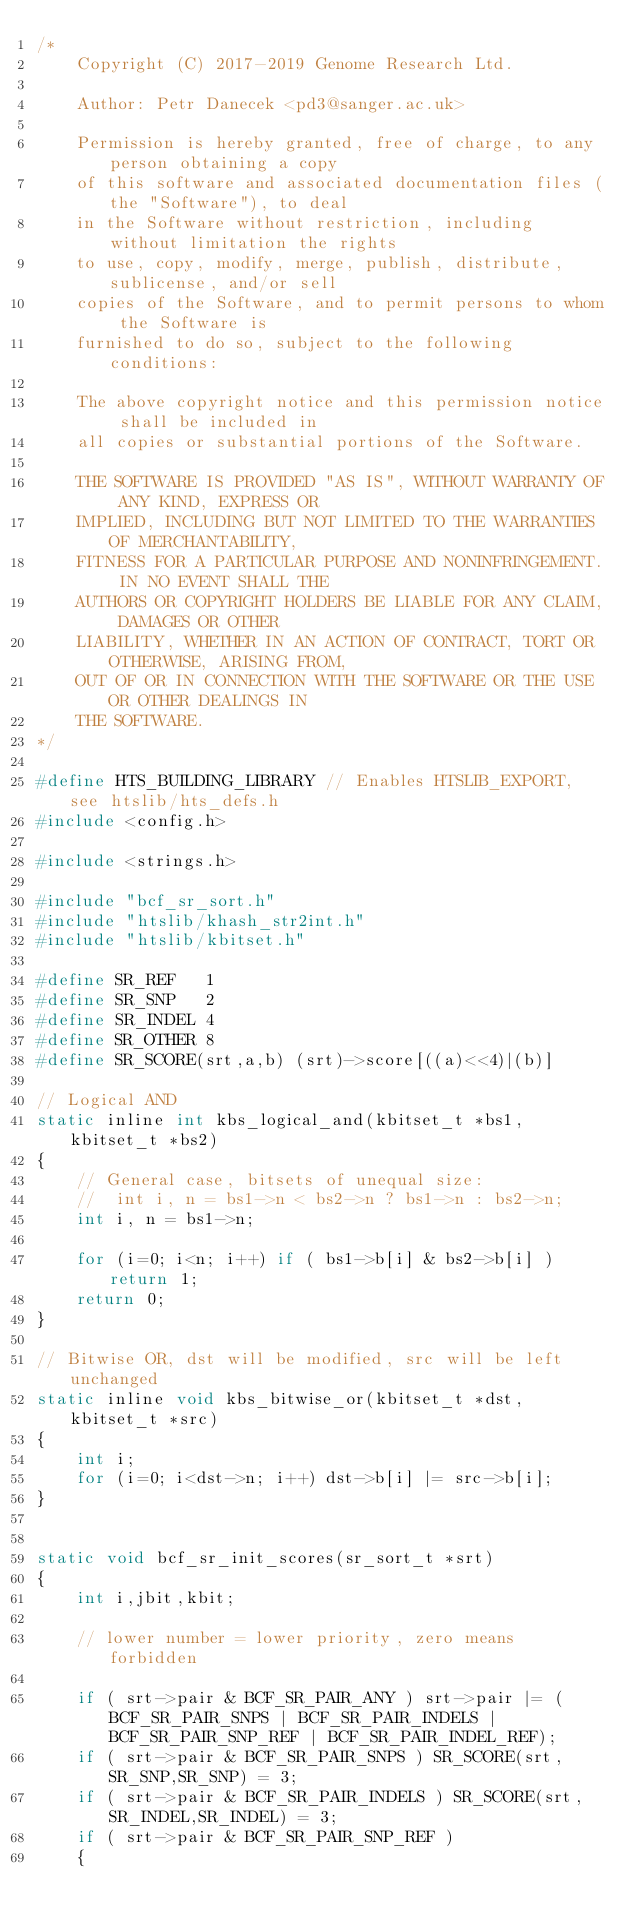Convert code to text. <code><loc_0><loc_0><loc_500><loc_500><_C_>/*
    Copyright (C) 2017-2019 Genome Research Ltd.

    Author: Petr Danecek <pd3@sanger.ac.uk>

    Permission is hereby granted, free of charge, to any person obtaining a copy
    of this software and associated documentation files (the "Software"), to deal
    in the Software without restriction, including without limitation the rights
    to use, copy, modify, merge, publish, distribute, sublicense, and/or sell
    copies of the Software, and to permit persons to whom the Software is
    furnished to do so, subject to the following conditions:

    The above copyright notice and this permission notice shall be included in
    all copies or substantial portions of the Software.

    THE SOFTWARE IS PROVIDED "AS IS", WITHOUT WARRANTY OF ANY KIND, EXPRESS OR
    IMPLIED, INCLUDING BUT NOT LIMITED TO THE WARRANTIES OF MERCHANTABILITY,
    FITNESS FOR A PARTICULAR PURPOSE AND NONINFRINGEMENT. IN NO EVENT SHALL THE
    AUTHORS OR COPYRIGHT HOLDERS BE LIABLE FOR ANY CLAIM, DAMAGES OR OTHER
    LIABILITY, WHETHER IN AN ACTION OF CONTRACT, TORT OR OTHERWISE, ARISING FROM,
    OUT OF OR IN CONNECTION WITH THE SOFTWARE OR THE USE OR OTHER DEALINGS IN
    THE SOFTWARE.
*/

#define HTS_BUILDING_LIBRARY // Enables HTSLIB_EXPORT, see htslib/hts_defs.h
#include <config.h>

#include <strings.h>

#include "bcf_sr_sort.h"
#include "htslib/khash_str2int.h"
#include "htslib/kbitset.h"

#define SR_REF   1
#define SR_SNP   2
#define SR_INDEL 4
#define SR_OTHER 8
#define SR_SCORE(srt,a,b) (srt)->score[((a)<<4)|(b)]

// Logical AND
static inline int kbs_logical_and(kbitset_t *bs1, kbitset_t *bs2)
{
    // General case, bitsets of unequal size:
    //  int i, n = bs1->n < bs2->n ? bs1->n : bs2->n;
    int i, n = bs1->n;

    for (i=0; i<n; i++) if ( bs1->b[i] & bs2->b[i] ) return 1;
    return 0;
}

// Bitwise OR, dst will be modified, src will be left unchanged
static inline void kbs_bitwise_or(kbitset_t *dst, kbitset_t *src)
{
    int i;
    for (i=0; i<dst->n; i++) dst->b[i] |= src->b[i];
}


static void bcf_sr_init_scores(sr_sort_t *srt)
{
    int i,jbit,kbit;

    // lower number = lower priority, zero means forbidden

    if ( srt->pair & BCF_SR_PAIR_ANY ) srt->pair |= (BCF_SR_PAIR_SNPS | BCF_SR_PAIR_INDELS | BCF_SR_PAIR_SNP_REF | BCF_SR_PAIR_INDEL_REF);
    if ( srt->pair & BCF_SR_PAIR_SNPS ) SR_SCORE(srt,SR_SNP,SR_SNP) = 3;
    if ( srt->pair & BCF_SR_PAIR_INDELS ) SR_SCORE(srt,SR_INDEL,SR_INDEL) = 3;
    if ( srt->pair & BCF_SR_PAIR_SNP_REF )
    {</code> 